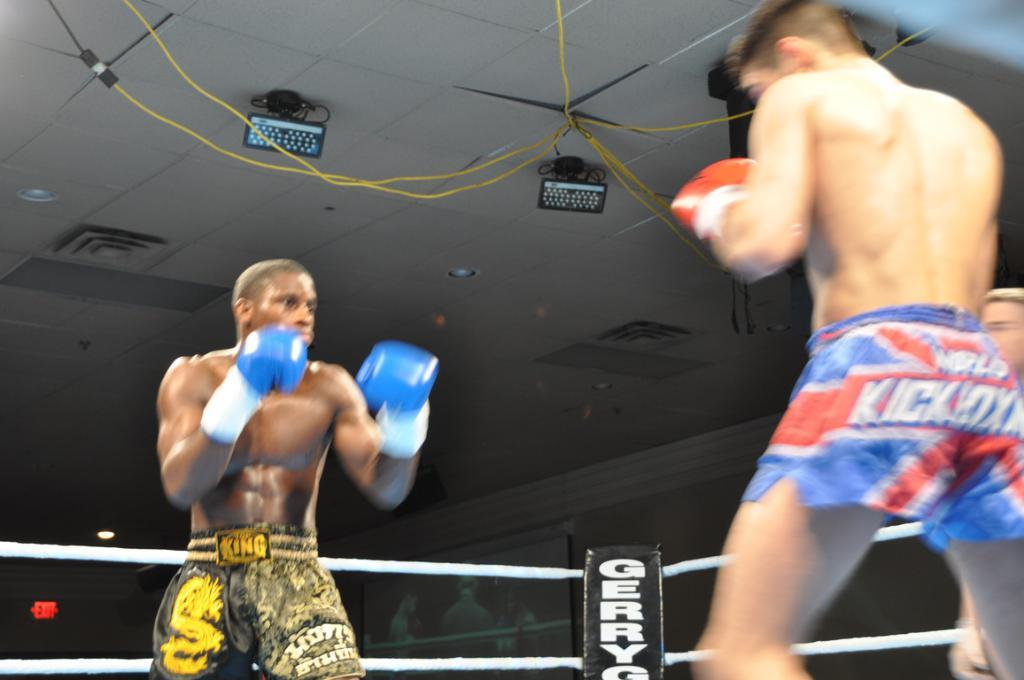<image>
Present a compact description of the photo's key features. The guy in the blue and red trunks is sponsored by a kick boxer association. 